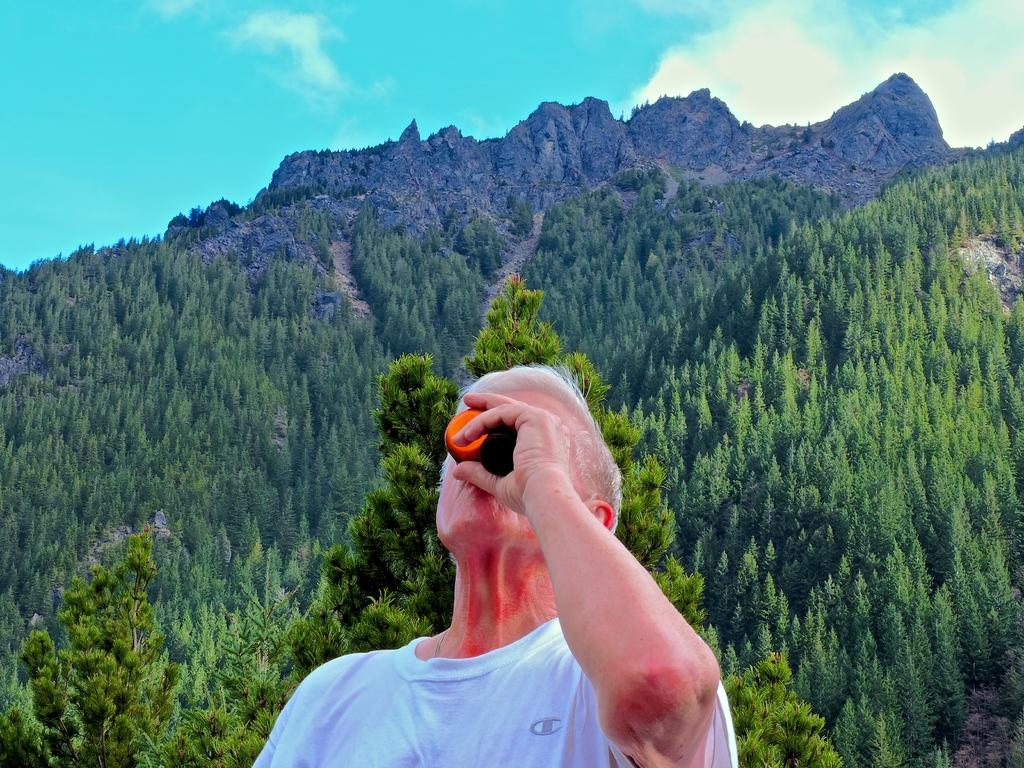What is the main subject in the foreground of the image? There is a man in the foreground of the image. What is the man wearing? The man is wearing a white t-shirt. What is the man holding in the image? The man is holding something. What can be seen in the background of the image? There are trees and hills in the background of the image. What is the condition of the sky in the image? The sky is cloudy in the image. How many apples can be seen on the man's head in the image? There are no apples present on the man's head in the image. What type of scissors is the man using to cut the trees in the background? There are no scissors visible in the image, and the man is not cutting any trees. 